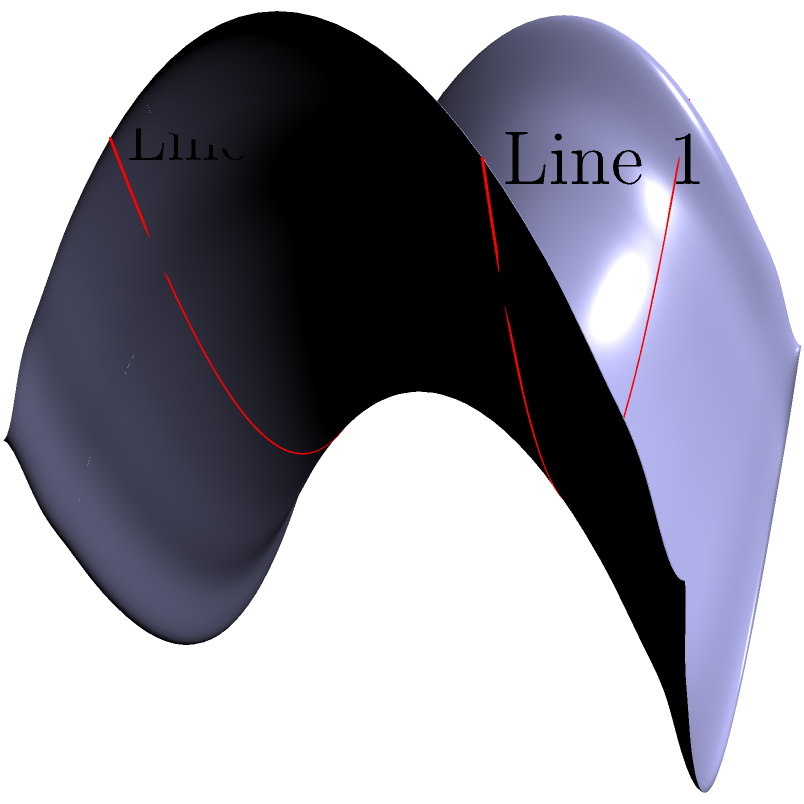On a saddle-shaped ice surface, two parallel lines of skate marks are observed as shown in the diagram. If these lines appear to converge at infinity on this non-Euclidean surface, what property of non-Euclidean geometry does this demonstrate, and how does it differ from Euclidean geometry? To understand this problem, let's break it down step-by-step:

1. In Euclidean geometry, parallel lines are defined as lines that never intersect, no matter how far they are extended.

2. The ice surface in the diagram is a saddle shape, which is an example of a hyperbolic surface in non-Euclidean geometry.

3. On a hyperbolic surface, the rules of Euclidean geometry no longer apply. One of the key differences is in how parallel lines behave.

4. In hyperbolic geometry, through a point not on a given line, there are at least two lines parallel to the given line. This is known as the hyperbolic parallel postulate.

5. As a result, on a saddle-shaped surface, lines that are parallel at one point may appear to converge or diverge when extended far enough.

6. In the diagram, the two red lines represent parallel skate marks on the ice. Although they start parallel, they appear to converge as they extend towards infinity on the saddle surface.

7. This convergence of initially parallel lines is a key property of hyperbolic geometry, demonstrating that the sum of the angles in a triangle on such a surface is less than 180 degrees.

8. The main difference from Euclidean geometry is that in Euclidean space, parallel lines remain equidistant and never converge or diverge.

This problem illustrates the violation of Euclid's fifth postulate (the parallel postulate) in non-Euclidean geometry, specifically in hyperbolic geometry.
Answer: Hyperbolic parallel postulate 